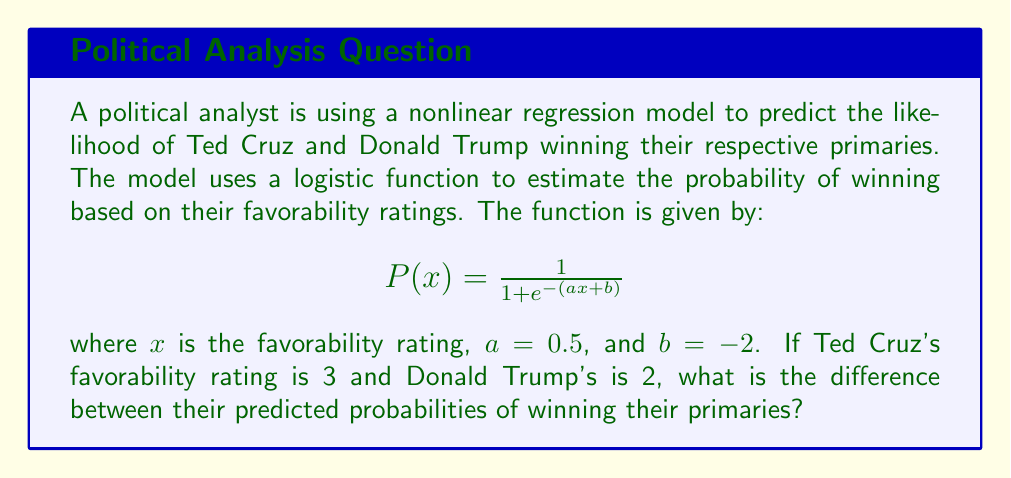Could you help me with this problem? To solve this problem, we need to follow these steps:

1. Calculate the probability for Ted Cruz:
   Let $x_C = 3$ (Cruz's favorability rating)
   $$P(x_C) = \frac{1}{1 + e^{-(0.5 \cdot 3 - 2)}}$$
   $$P(x_C) = \frac{1}{1 + e^{-(-0.5)}}$$
   $$P(x_C) = \frac{1}{1 + e^{0.5}}$$
   $$P(x_C) \approx 0.3775$$

2. Calculate the probability for Donald Trump:
   Let $x_T = 2$ (Trump's favorability rating)
   $$P(x_T) = \frac{1}{1 + e^{-(0.5 \cdot 2 - 2)}}$$
   $$P(x_T) = \frac{1}{1 + e^{-(-1)}}$$
   $$P(x_T) = \frac{1}{1 + e}$$
   $$P(x_T) \approx 0.2689$$

3. Calculate the difference between the two probabilities:
   $$\text{Difference} = P(x_C) - P(x_T)$$
   $$\text{Difference} \approx 0.3775 - 0.2689$$
   $$\text{Difference} \approx 0.1086$$
Answer: 0.1086 